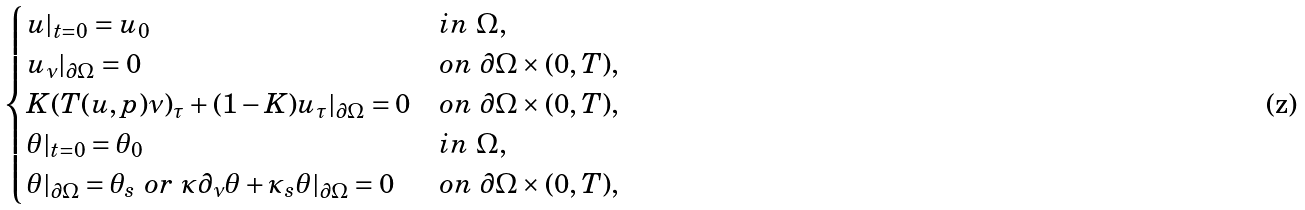Convert formula to latex. <formula><loc_0><loc_0><loc_500><loc_500>\begin{cases} u | _ { t = 0 } = u _ { 0 } & i n \ \Omega , \\ u _ { \nu } | _ { \partial \Omega } = 0 & o n \ \partial \Omega \times ( 0 , T ) , \\ K ( T ( u , p ) \nu ) _ { \tau } + ( 1 - K ) u _ { \tau } | _ { \partial \Omega } = 0 & o n \ \partial \Omega \times ( 0 , T ) , \\ \theta | _ { t = 0 } = \theta _ { 0 } & i n \ \Omega , \\ \theta | _ { \partial \Omega } = \theta _ { s } \ o r \ \kappa \partial _ { \nu } \theta + \kappa _ { s } \theta | _ { \partial \Omega } = 0 & o n \ \partial \Omega \times ( 0 , T ) , \end{cases}</formula> 